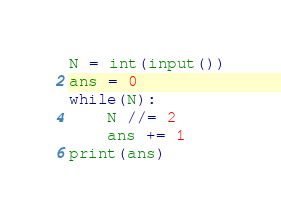Convert code to text. <code><loc_0><loc_0><loc_500><loc_500><_Python_>N = int(input())
ans = 0
while(N):
    N //= 2
    ans += 1
print(ans)
</code> 